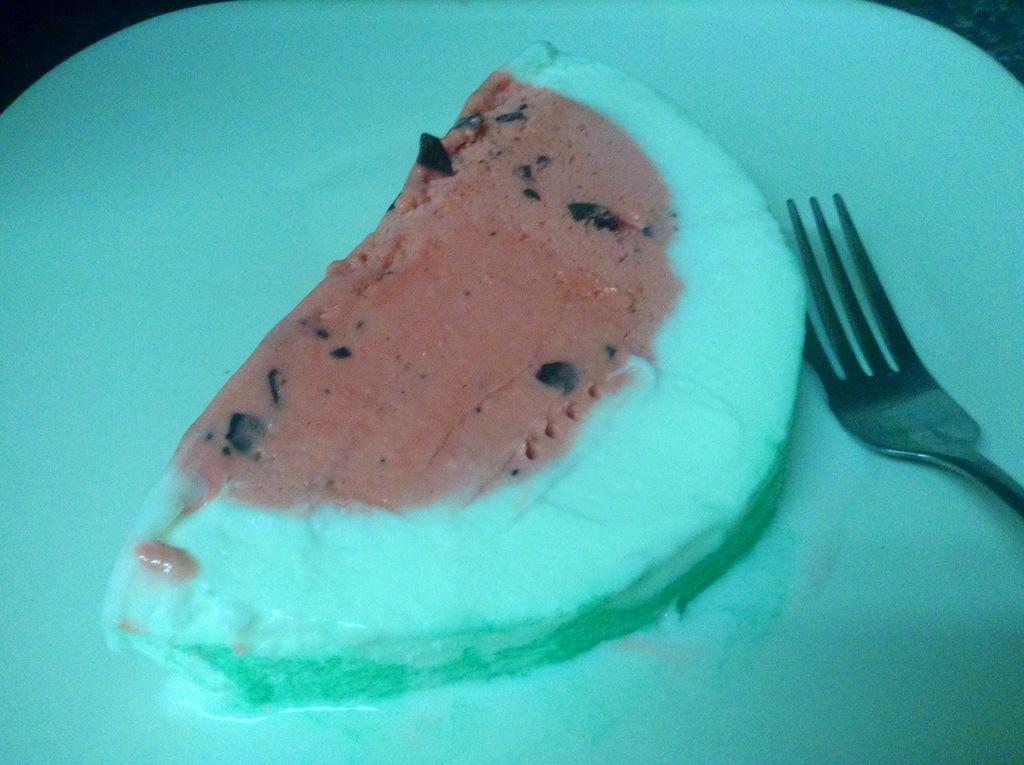What is present in the image related to food? There is food in the image. Can you describe the utensil and plate in the image? There is a fork on a white plate in the image. How quiet is the hour depicted in the image? The image does not depict an hour or any time-related information, so it cannot be determined how quiet it is. 